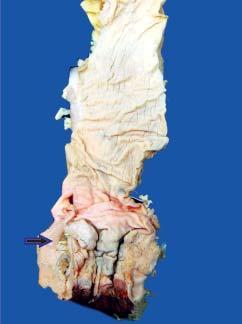what shows an ulcerated mucosa with thickened wall?
Answer the question using a single word or phrase. Anorectal margin 